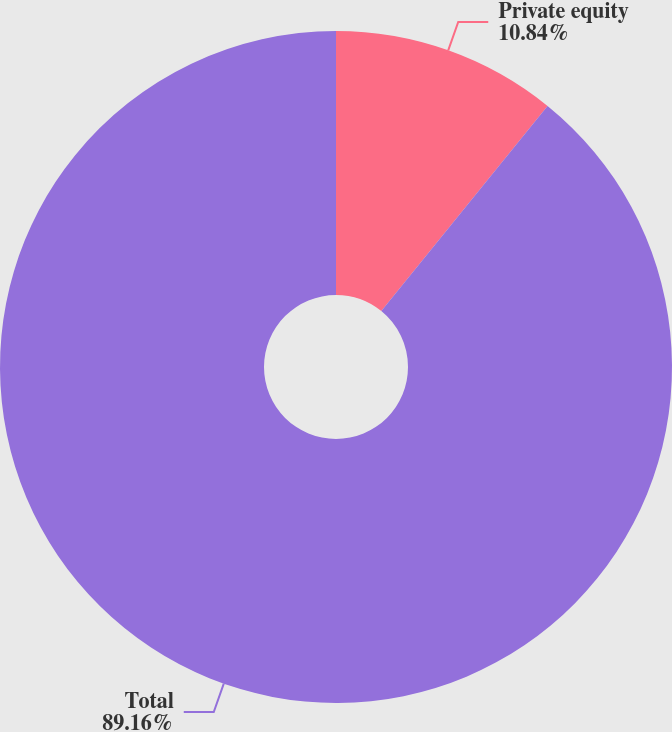Convert chart to OTSL. <chart><loc_0><loc_0><loc_500><loc_500><pie_chart><fcel>Private equity<fcel>Total<nl><fcel>10.84%<fcel>89.16%<nl></chart> 